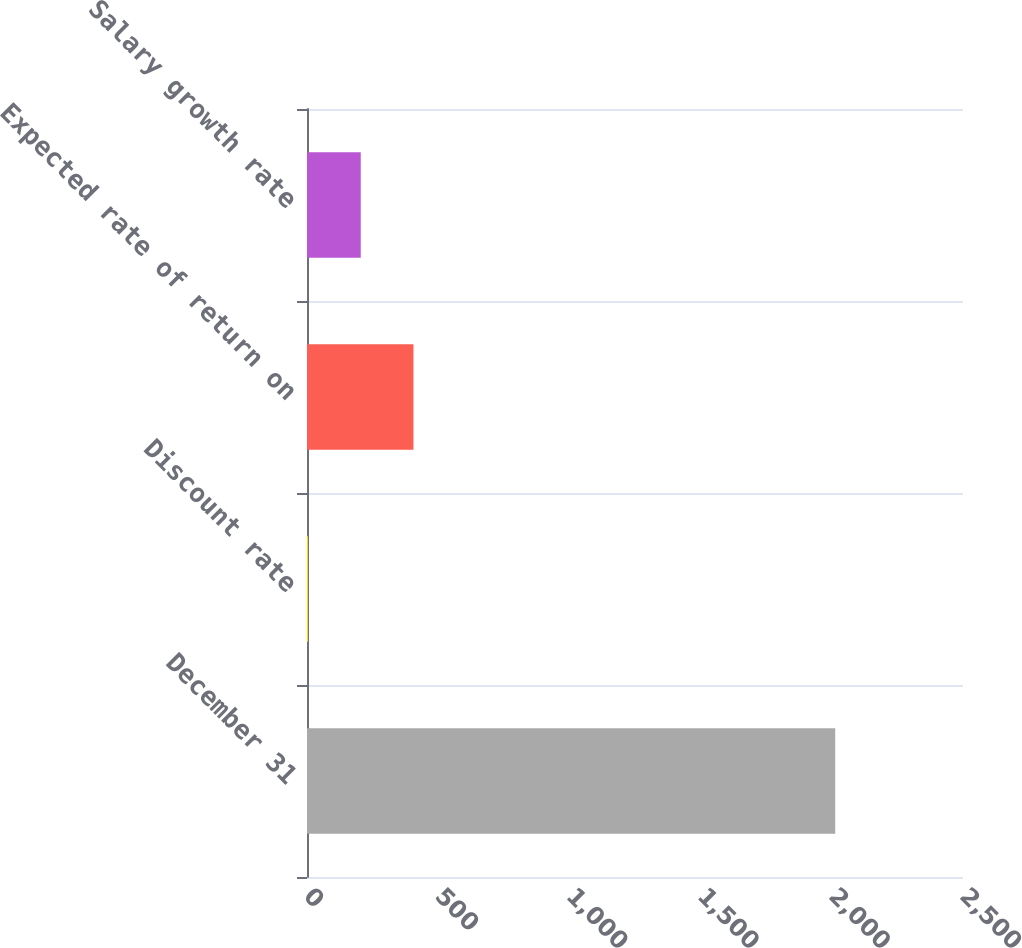<chart> <loc_0><loc_0><loc_500><loc_500><bar_chart><fcel>December 31<fcel>Discount rate<fcel>Expected rate of return on<fcel>Salary growth rate<nl><fcel>2013<fcel>3.9<fcel>405.72<fcel>204.81<nl></chart> 